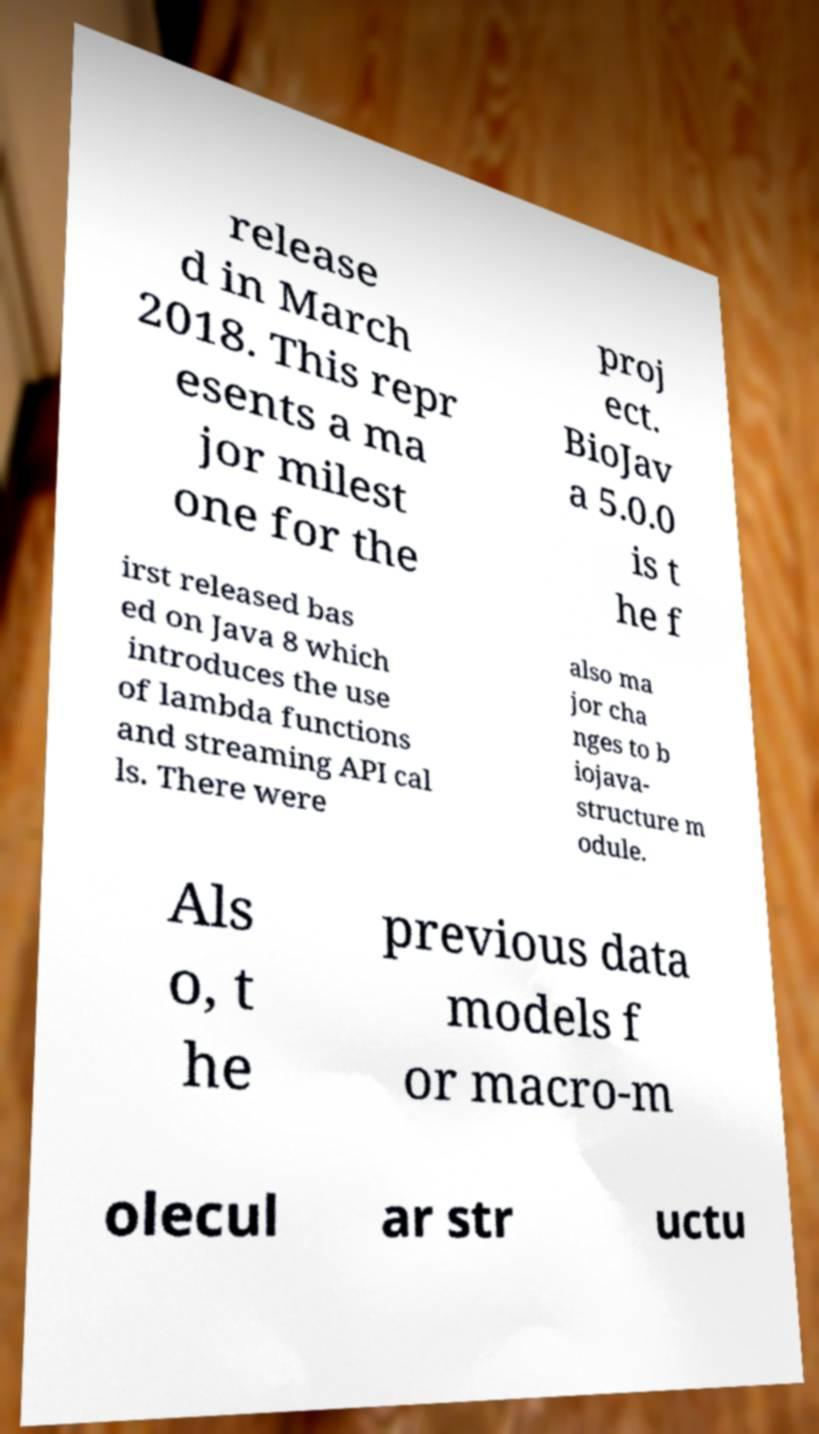There's text embedded in this image that I need extracted. Can you transcribe it verbatim? release d in March 2018. This repr esents a ma jor milest one for the proj ect. BioJav a 5.0.0 is t he f irst released bas ed on Java 8 which introduces the use of lambda functions and streaming API cal ls. There were also ma jor cha nges to b iojava- structure m odule. Als o, t he previous data models f or macro-m olecul ar str uctu 